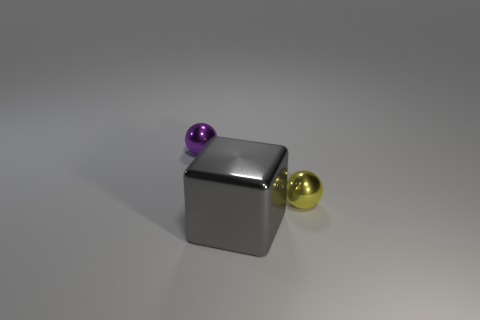There is a purple object; is it the same size as the gray thing in front of the tiny yellow metallic ball?
Give a very brief answer. No. There is a big shiny object in front of the sphere that is on the right side of the purple metallic object; what color is it?
Your response must be concise. Gray. What number of other objects are the same color as the metallic block?
Give a very brief answer. 0. What size is the yellow metal sphere?
Your answer should be very brief. Small. Are there more gray cubes that are on the left side of the purple metal ball than gray metallic blocks that are to the right of the tiny yellow metal thing?
Give a very brief answer. No. How many yellow balls are left of the sphere that is to the right of the purple sphere?
Provide a short and direct response. 0. Do the tiny shiny object that is left of the big gray block and the gray object have the same shape?
Your answer should be very brief. No. There is another object that is the same shape as the small yellow thing; what material is it?
Make the answer very short. Metal. How many other metallic cubes are the same size as the gray cube?
Offer a very short reply. 0. The shiny thing that is both to the left of the yellow sphere and behind the gray shiny block is what color?
Offer a very short reply. Purple. 